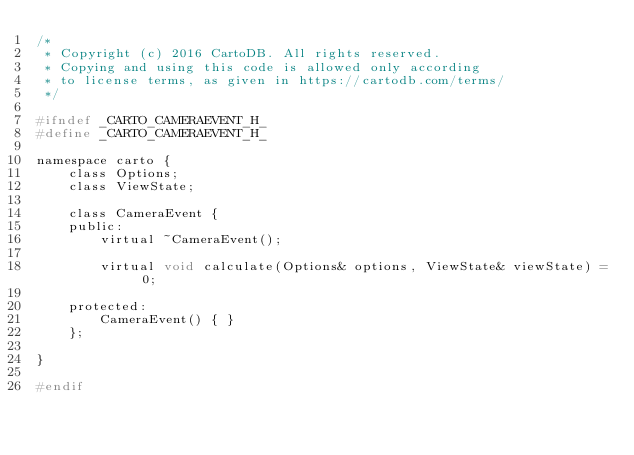Convert code to text. <code><loc_0><loc_0><loc_500><loc_500><_C_>/*
 * Copyright (c) 2016 CartoDB. All rights reserved.
 * Copying and using this code is allowed only according
 * to license terms, as given in https://cartodb.com/terms/
 */

#ifndef _CARTO_CAMERAEVENT_H_
#define _CARTO_CAMERAEVENT_H_

namespace carto {
    class Options;
    class ViewState;
    
    class CameraEvent {
    public:
        virtual ~CameraEvent();
    
        virtual void calculate(Options& options, ViewState& viewState) = 0;
    
    protected:
        CameraEvent() { }
    };
    
}

#endif
</code> 